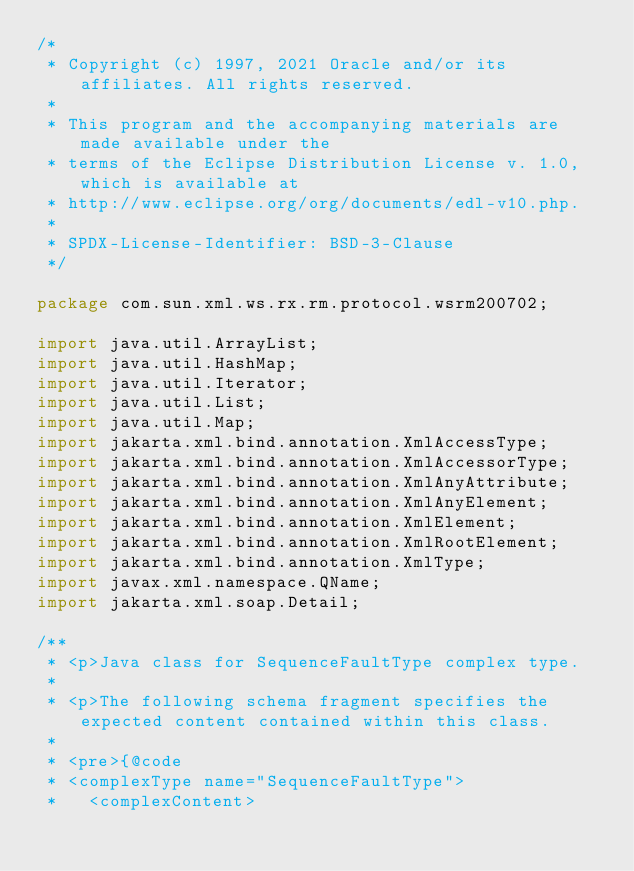Convert code to text. <code><loc_0><loc_0><loc_500><loc_500><_Java_>/*
 * Copyright (c) 1997, 2021 Oracle and/or its affiliates. All rights reserved.
 *
 * This program and the accompanying materials are made available under the
 * terms of the Eclipse Distribution License v. 1.0, which is available at
 * http://www.eclipse.org/org/documents/edl-v10.php.
 *
 * SPDX-License-Identifier: BSD-3-Clause
 */

package com.sun.xml.ws.rx.rm.protocol.wsrm200702;

import java.util.ArrayList;
import java.util.HashMap;
import java.util.Iterator;
import java.util.List;
import java.util.Map;
import jakarta.xml.bind.annotation.XmlAccessType;
import jakarta.xml.bind.annotation.XmlAccessorType;
import jakarta.xml.bind.annotation.XmlAnyAttribute;
import jakarta.xml.bind.annotation.XmlAnyElement;
import jakarta.xml.bind.annotation.XmlElement;
import jakarta.xml.bind.annotation.XmlRootElement;
import jakarta.xml.bind.annotation.XmlType;
import javax.xml.namespace.QName;
import jakarta.xml.soap.Detail;

/**
 * <p>Java class for SequenceFaultType complex type.
 * 
 * <p>The following schema fragment specifies the expected content contained within this class.
 * 
 * <pre>{@code
 * <complexType name="SequenceFaultType">
 *   <complexContent></code> 